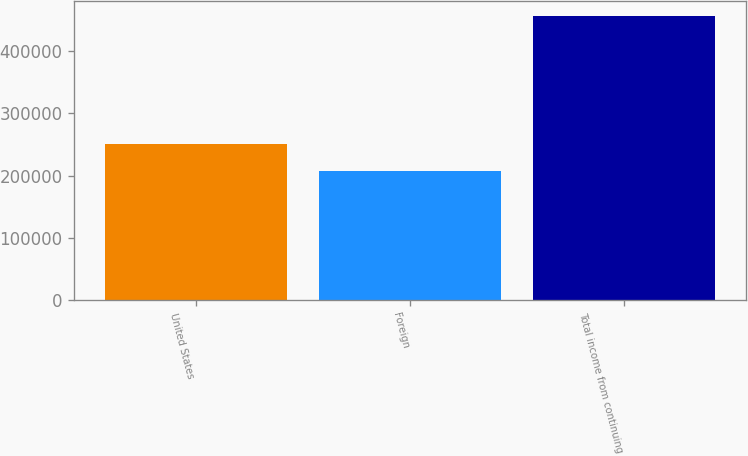Convert chart. <chart><loc_0><loc_0><loc_500><loc_500><bar_chart><fcel>United States<fcel>Foreign<fcel>Total income from continuing<nl><fcel>250041<fcel>206730<fcel>456771<nl></chart> 